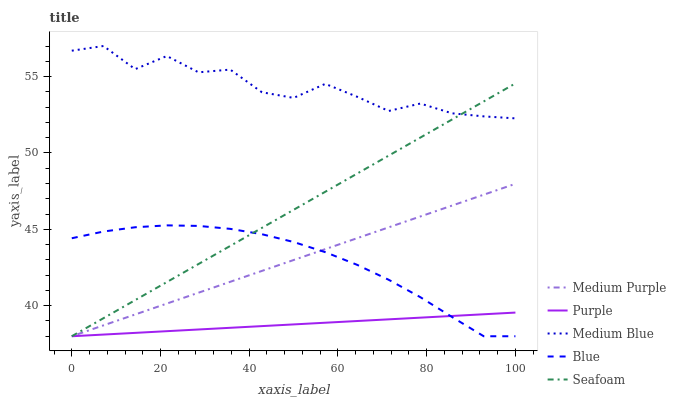Does Purple have the minimum area under the curve?
Answer yes or no. Yes. Does Medium Blue have the maximum area under the curve?
Answer yes or no. Yes. Does Medium Blue have the minimum area under the curve?
Answer yes or no. No. Does Purple have the maximum area under the curve?
Answer yes or no. No. Is Purple the smoothest?
Answer yes or no. Yes. Is Medium Blue the roughest?
Answer yes or no. Yes. Is Medium Blue the smoothest?
Answer yes or no. No. Is Purple the roughest?
Answer yes or no. No. Does Medium Purple have the lowest value?
Answer yes or no. Yes. Does Medium Blue have the lowest value?
Answer yes or no. No. Does Medium Blue have the highest value?
Answer yes or no. Yes. Does Purple have the highest value?
Answer yes or no. No. Is Purple less than Medium Blue?
Answer yes or no. Yes. Is Medium Blue greater than Blue?
Answer yes or no. Yes. Does Blue intersect Seafoam?
Answer yes or no. Yes. Is Blue less than Seafoam?
Answer yes or no. No. Is Blue greater than Seafoam?
Answer yes or no. No. Does Purple intersect Medium Blue?
Answer yes or no. No. 